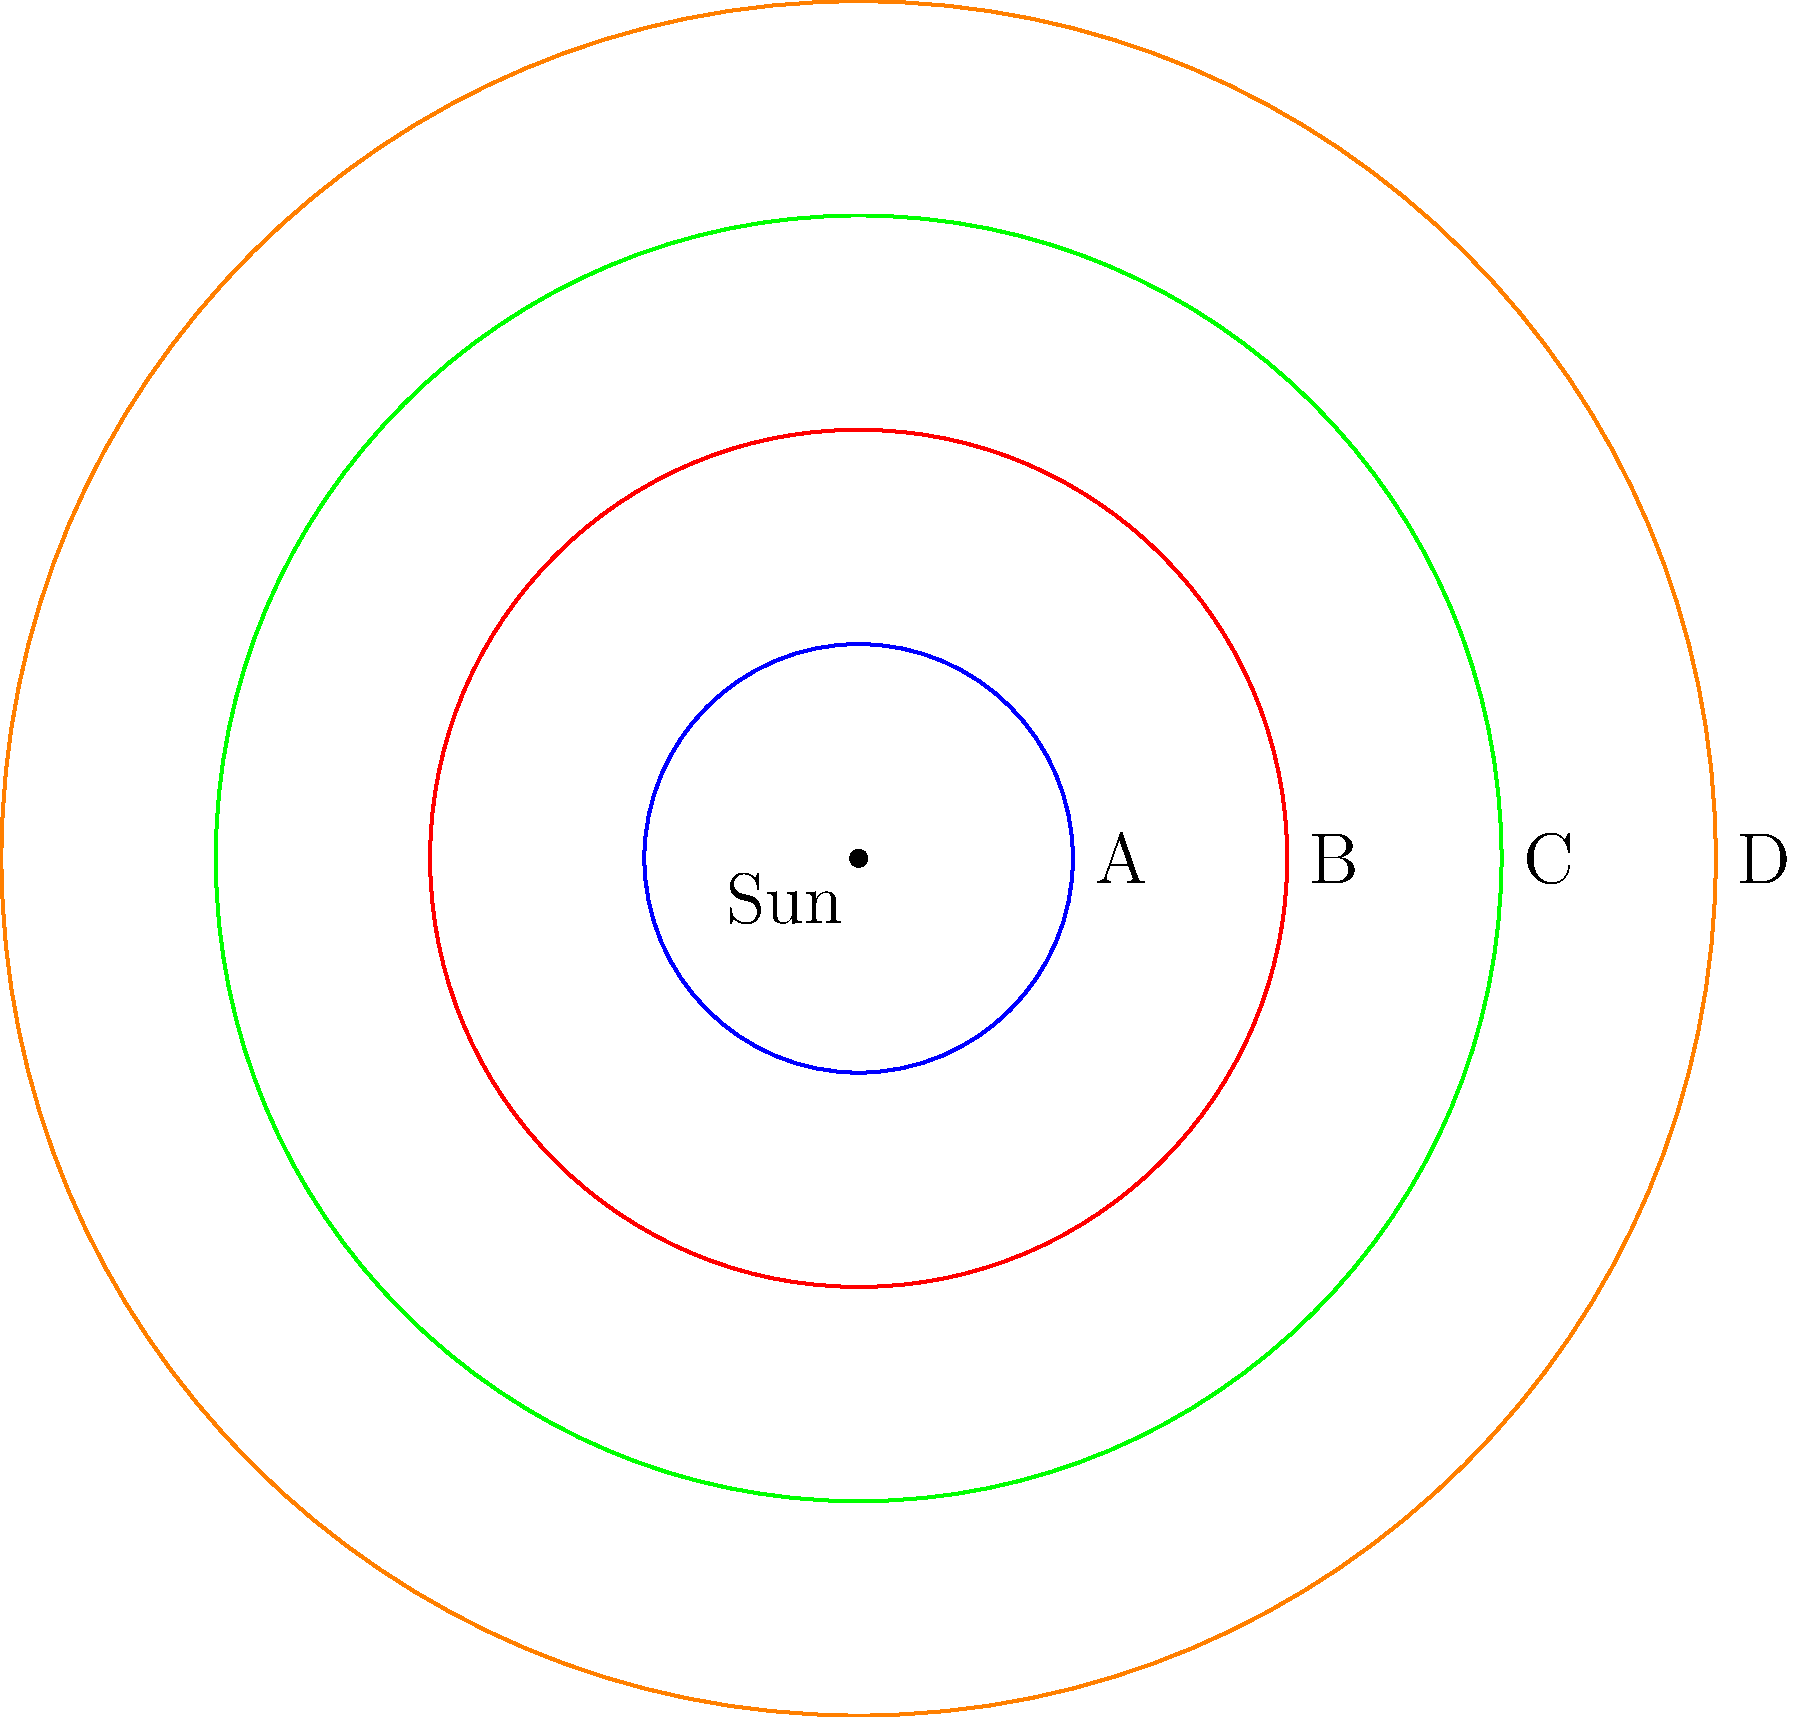Hey, remember that astronomy book Peter Konsterlie lent us? It had this cool diagram of planet sizes and distances. If A represents Earth, which planet do you think B might represent, considering its relative size and distance from the Sun? Let's think through this step-by-step:

1. We know that A represents Earth in this diagram.
2. B is the next larger circle, indicating a planet larger than Earth and farther from the Sun.
3. In our solar system, the planets in order from the Sun are: Mercury, Venus, Earth, Mars, Jupiter, Saturn, Uranus, Neptune.
4. Mars is smaller than Earth, so it can't be B.
5. The next planet after Earth is Jupiter, which is significantly larger than Earth.
6. Jupiter is about 11 times the diameter of Earth, which seems to match the relative size difference between A and B in the diagram.
7. The distance ratio also appears to be roughly correct, as Jupiter is about 5.2 AU from the Sun, while Earth is 1 AU.

Therefore, based on its size and position relative to Earth, B most likely represents Jupiter.
Answer: Jupiter 